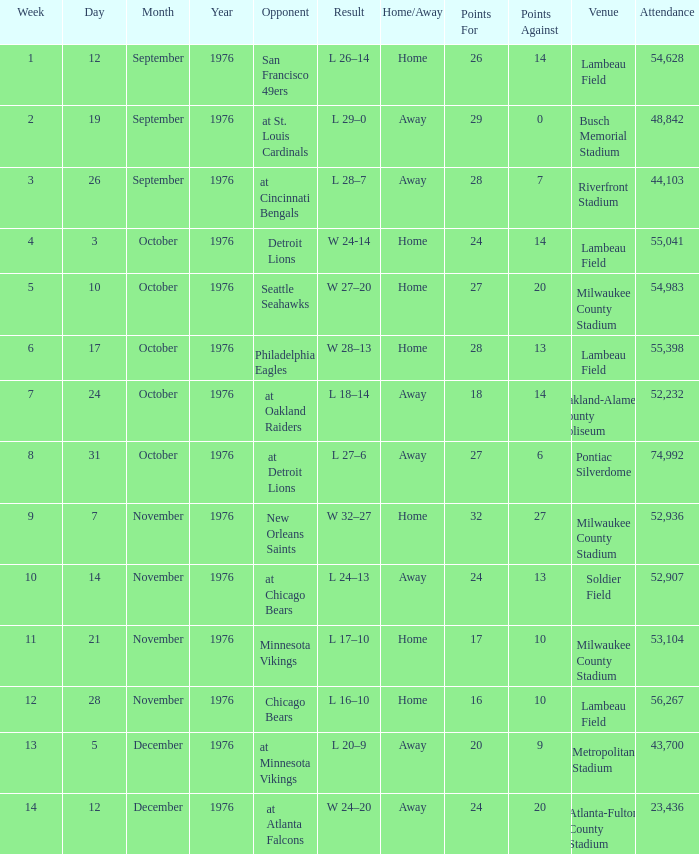For the game held on september 26, 1976, what was the usual attendance figure? 44103.0. 